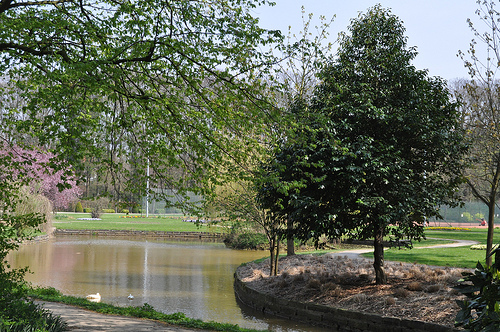<image>
Is the water to the right of the tree? No. The water is not to the right of the tree. The horizontal positioning shows a different relationship. 